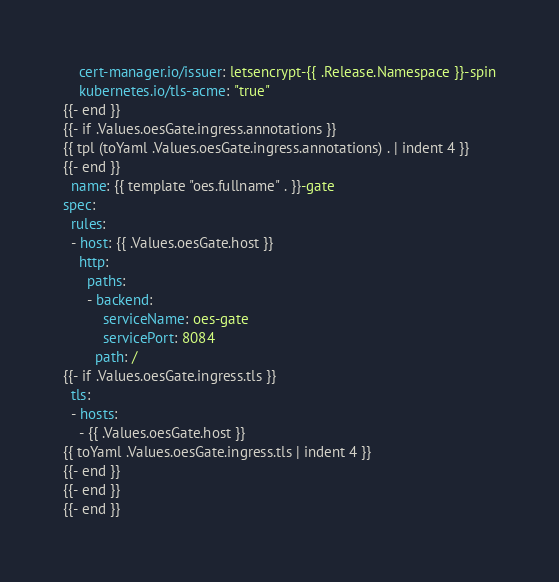<code> <loc_0><loc_0><loc_500><loc_500><_YAML_>    cert-manager.io/issuer: letsencrypt-{{ .Release.Namespace }}-spin
    kubernetes.io/tls-acme: "true"
{{- end }}
{{- if .Values.oesGate.ingress.annotations }}
{{ tpl (toYaml .Values.oesGate.ingress.annotations) . | indent 4 }}
{{- end }}
  name: {{ template "oes.fullname" . }}-gate
spec:
  rules:
  - host: {{ .Values.oesGate.host }}
    http:
      paths:
      - backend:
          serviceName: oes-gate
          servicePort: 8084
        path: /
{{- if .Values.oesGate.ingress.tls }}
  tls:
  - hosts:
    - {{ .Values.oesGate.host }}
{{ toYaml .Values.oesGate.ingress.tls | indent 4 }}
{{- end }}
{{- end }}
{{- end }}
</code> 